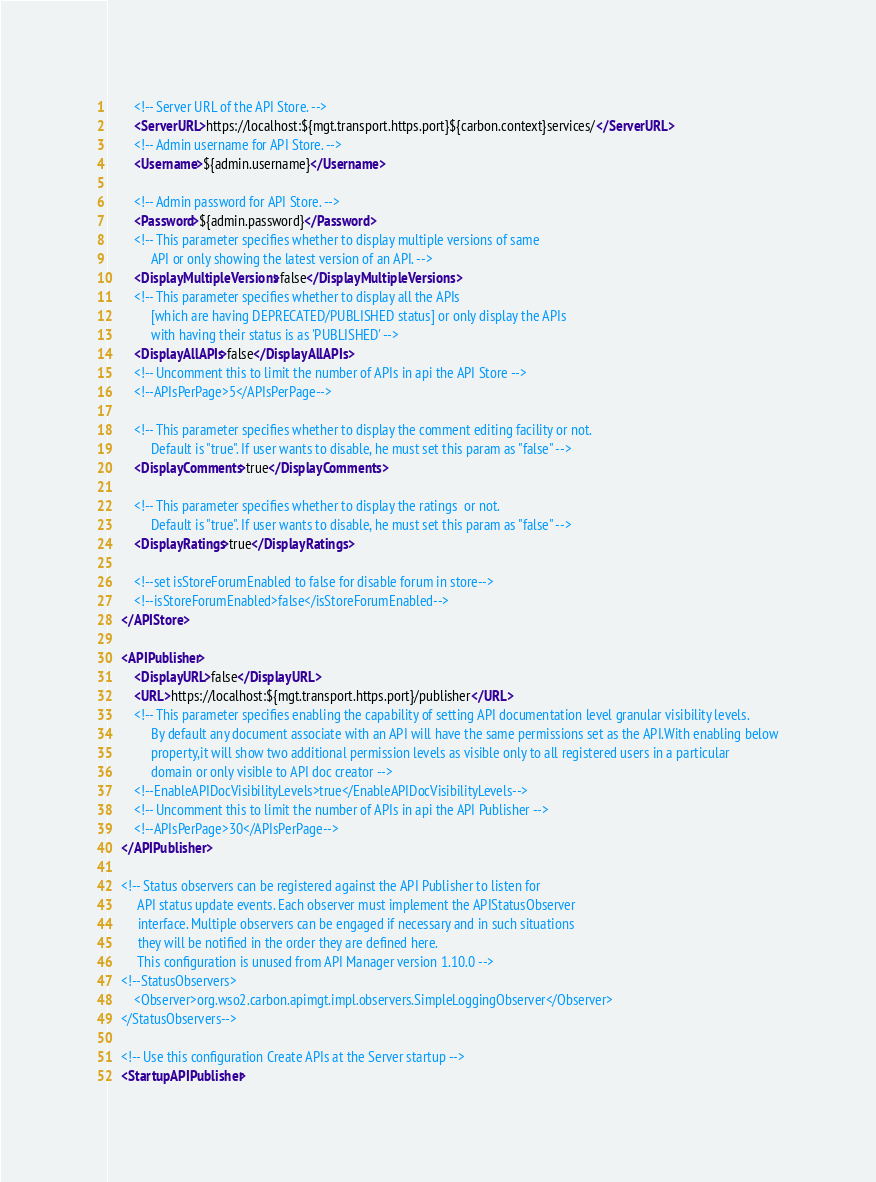Convert code to text. <code><loc_0><loc_0><loc_500><loc_500><_XML_>        <!-- Server URL of the API Store. -->
        <ServerURL>https://localhost:${mgt.transport.https.port}${carbon.context}services/</ServerURL>
        <!-- Admin username for API Store. -->
        <Username>${admin.username}</Username>

        <!-- Admin password for API Store. -->
        <Password>${admin.password}</Password>
        <!-- This parameter specifies whether to display multiple versions of same
             API or only showing the latest version of an API. -->
        <DisplayMultipleVersions>false</DisplayMultipleVersions>
        <!-- This parameter specifies whether to display all the APIs
             [which are having DEPRECATED/PUBLISHED status] or only display the APIs
             with having their status is as 'PUBLISHED' -->
        <DisplayAllAPIs>false</DisplayAllAPIs>
        <!-- Uncomment this to limit the number of APIs in api the API Store -->
        <!--APIsPerPage>5</APIsPerPage-->

        <!-- This parameter specifies whether to display the comment editing facility or not.
             Default is "true". If user wants to disable, he must set this param as "false" -->
        <DisplayComments>true</DisplayComments>

        <!-- This parameter specifies whether to display the ratings  or not.
             Default is "true". If user wants to disable, he must set this param as "false" -->
        <DisplayRatings>true</DisplayRatings>

        <!--set isStoreForumEnabled to false for disable forum in store-->
        <!--isStoreForumEnabled>false</isStoreForumEnabled-->
    </APIStore>

    <APIPublisher>
        <DisplayURL>false</DisplayURL>
        <URL>https://localhost:${mgt.transport.https.port}/publisher</URL>
        <!-- This parameter specifies enabling the capability of setting API documentation level granular visibility levels.
             By default any document associate with an API will have the same permissions set as the API.With enabling below
             property,it will show two additional permission levels as visible only to all registered users in a particular
             domain or only visible to API doc creator -->
        <!--EnableAPIDocVisibilityLevels>true</EnableAPIDocVisibilityLevels-->
        <!-- Uncomment this to limit the number of APIs in api the API Publisher -->
        <!--APIsPerPage>30</APIsPerPage-->
    </APIPublisher>

    <!-- Status observers can be registered against the API Publisher to listen for
         API status update events. Each observer must implement the APIStatusObserver
         interface. Multiple observers can be engaged if necessary and in such situations
         they will be notified in the order they are defined here. 
         This configuration is unused from API Manager version 1.10.0 -->
    <!--StatusObservers>
        <Observer>org.wso2.carbon.apimgt.impl.observers.SimpleLoggingObserver</Observer>
    </StatusObservers-->

    <!-- Use this configuration Create APIs at the Server startup -->
    <StartupAPIPublisher></code> 